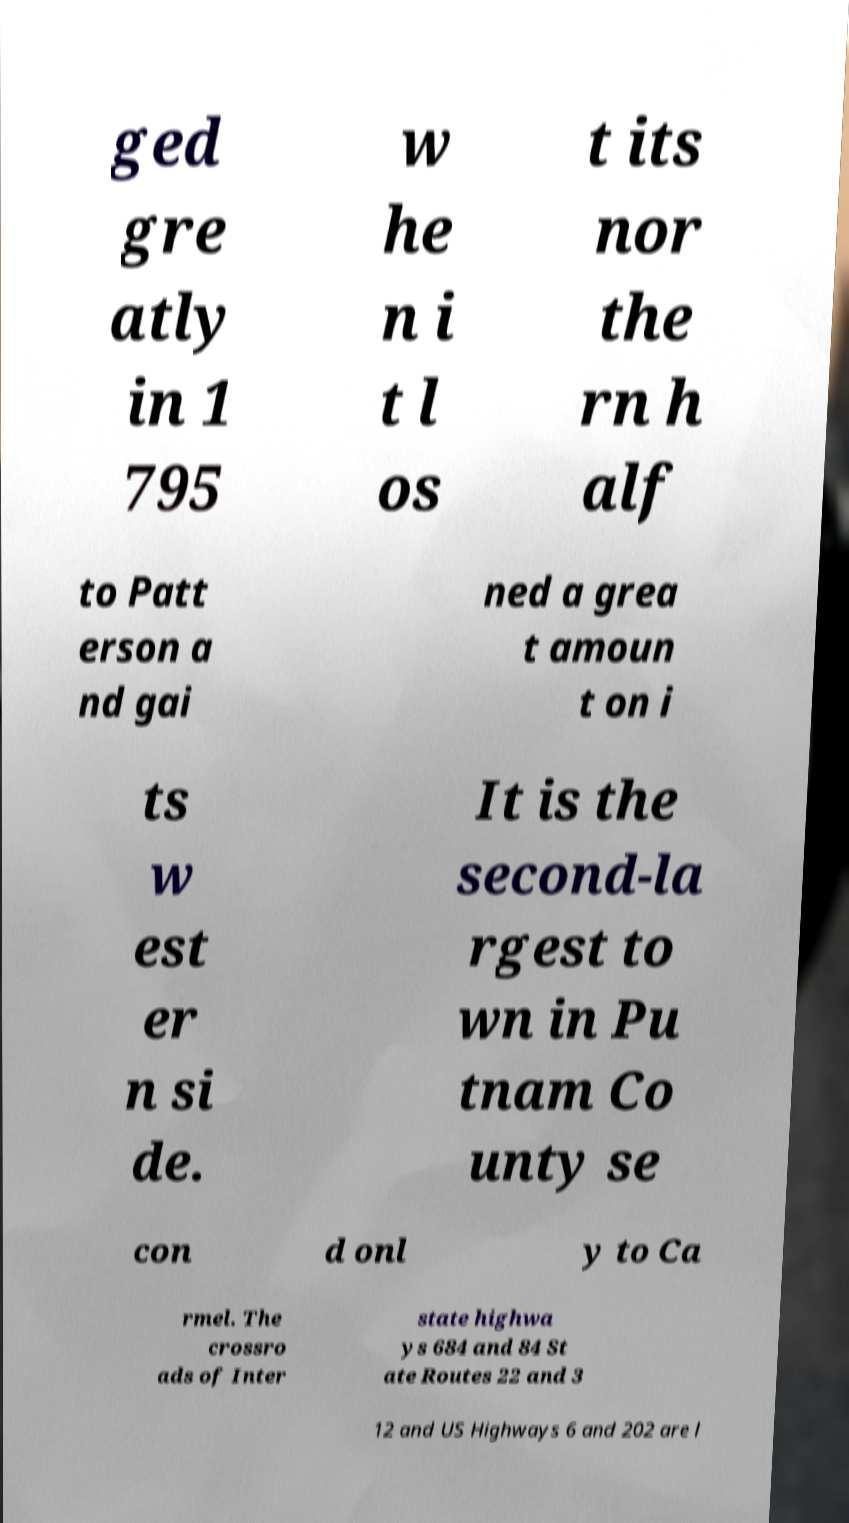Can you read and provide the text displayed in the image?This photo seems to have some interesting text. Can you extract and type it out for me? ged gre atly in 1 795 w he n i t l os t its nor the rn h alf to Patt erson a nd gai ned a grea t amoun t on i ts w est er n si de. It is the second-la rgest to wn in Pu tnam Co unty se con d onl y to Ca rmel. The crossro ads of Inter state highwa ys 684 and 84 St ate Routes 22 and 3 12 and US Highways 6 and 202 are l 